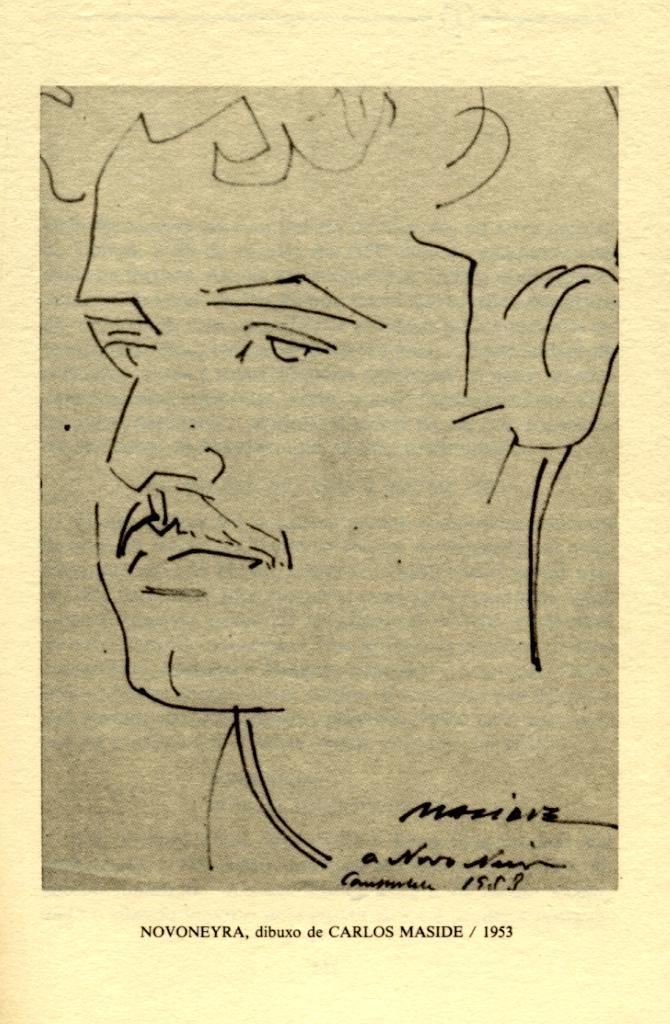What type of paper is visible in the image? There is a magazine paper in the image. What is depicted on the magazine paper? The magazine paper contains a sketch of a man's face. Are there any other elements present on the magazine paper? Yes, there are signatures under the sketch. How many girls are visible in the image? There are no girls present in the image; it features a magazine paper with a sketch of a man's face and signatures. What type of car is shown in the image? There is no car present in the image. 